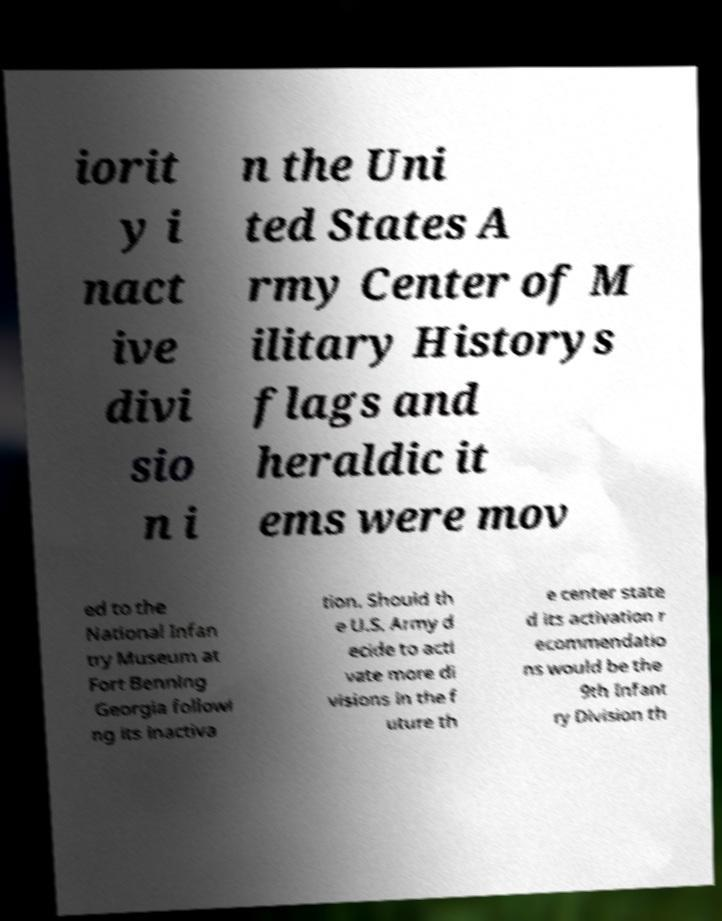Please read and relay the text visible in this image. What does it say? iorit y i nact ive divi sio n i n the Uni ted States A rmy Center of M ilitary Historys flags and heraldic it ems were mov ed to the National Infan try Museum at Fort Benning Georgia followi ng its inactiva tion. Should th e U.S. Army d ecide to acti vate more di visions in the f uture th e center state d its activation r ecommendatio ns would be the 9th Infant ry Division th 